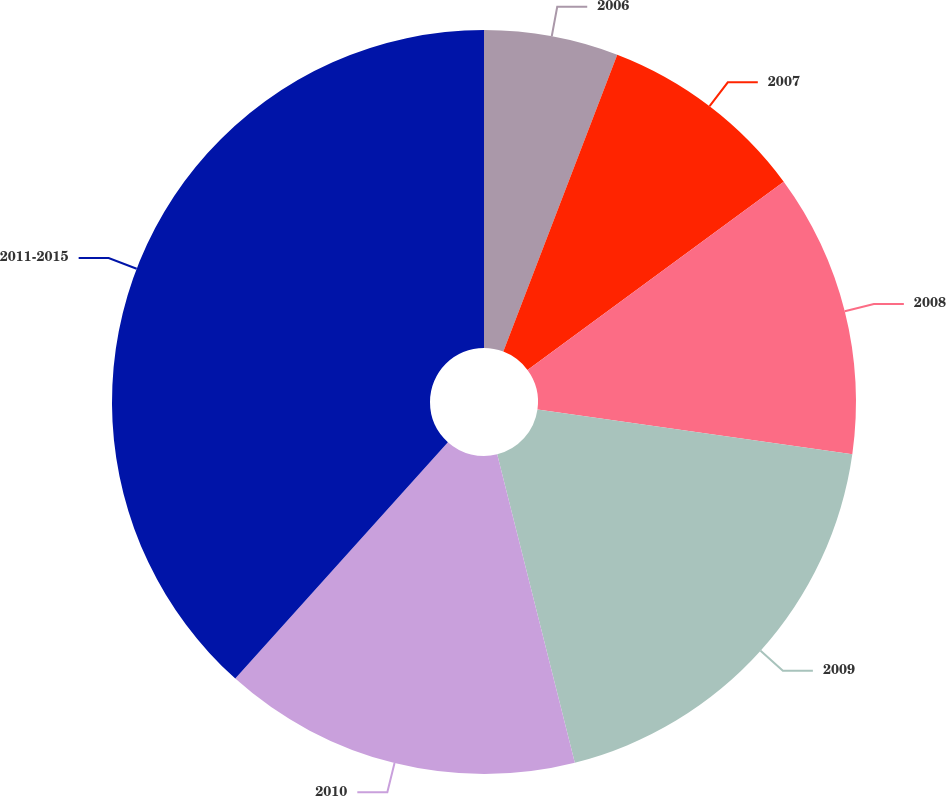Convert chart. <chart><loc_0><loc_0><loc_500><loc_500><pie_chart><fcel>2006<fcel>2007<fcel>2008<fcel>2009<fcel>2010<fcel>2011-2015<nl><fcel>5.83%<fcel>9.08%<fcel>12.33%<fcel>18.83%<fcel>15.58%<fcel>38.34%<nl></chart> 